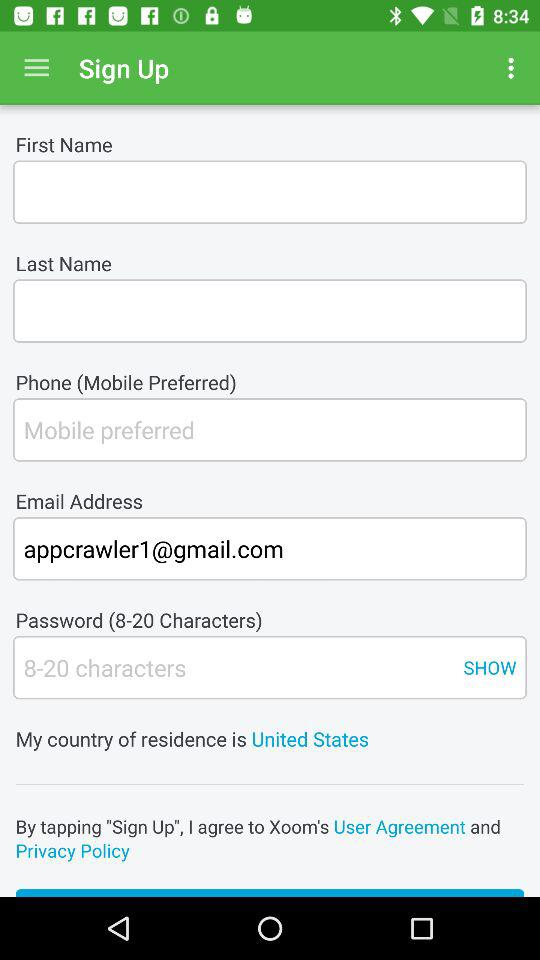How many characters should be in the password? There should be 8 to 20 characters in the password. 